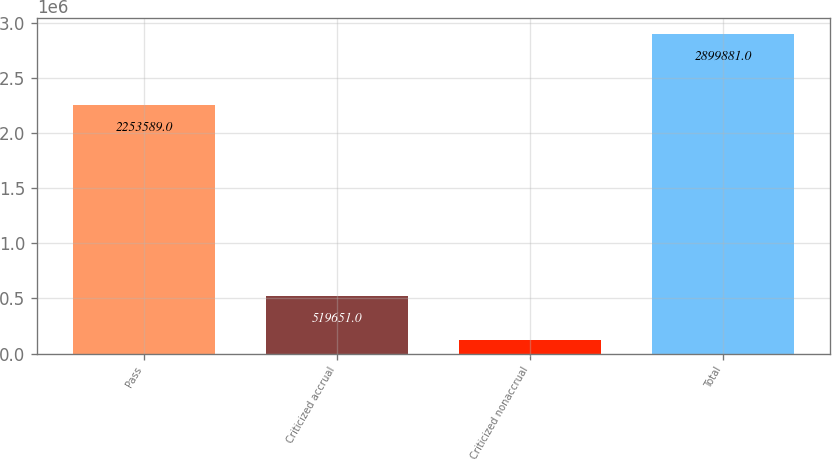<chart> <loc_0><loc_0><loc_500><loc_500><bar_chart><fcel>Pass<fcel>Criticized accrual<fcel>Criticized nonaccrual<fcel>Total<nl><fcel>2.25359e+06<fcel>519651<fcel>126641<fcel>2.89988e+06<nl></chart> 